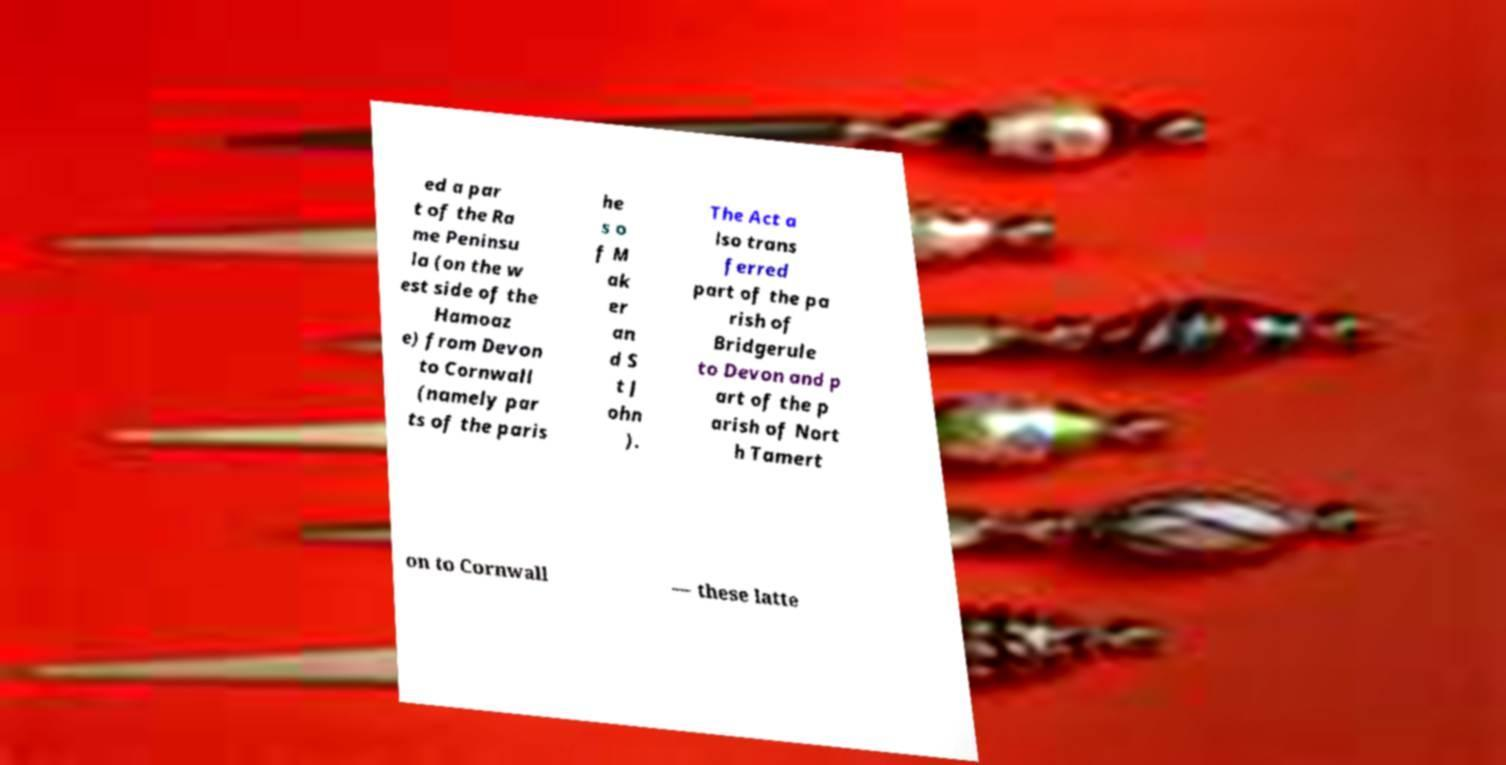Please read and relay the text visible in this image. What does it say? ed a par t of the Ra me Peninsu la (on the w est side of the Hamoaz e) from Devon to Cornwall (namely par ts of the paris he s o f M ak er an d S t J ohn ). The Act a lso trans ferred part of the pa rish of Bridgerule to Devon and p art of the p arish of Nort h Tamert on to Cornwall — these latte 